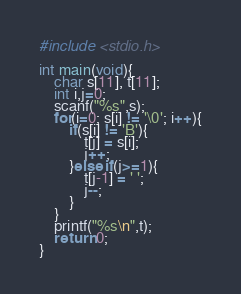Convert code to text. <code><loc_0><loc_0><loc_500><loc_500><_C_>#include <stdio.h>

int main(void){
    char s[11], t[11];
    int i,j=0;
    scanf("%s",s);
    for(i=0; s[i] != '\0'; i++){
        if(s[i] != 'B'){
            t[j] = s[i];
            j++;
        }else if(j>=1){
            t[j-1] = ' ';
            j--;
        }
    }
    printf("%s\n",t);
    return 0;
}
</code> 